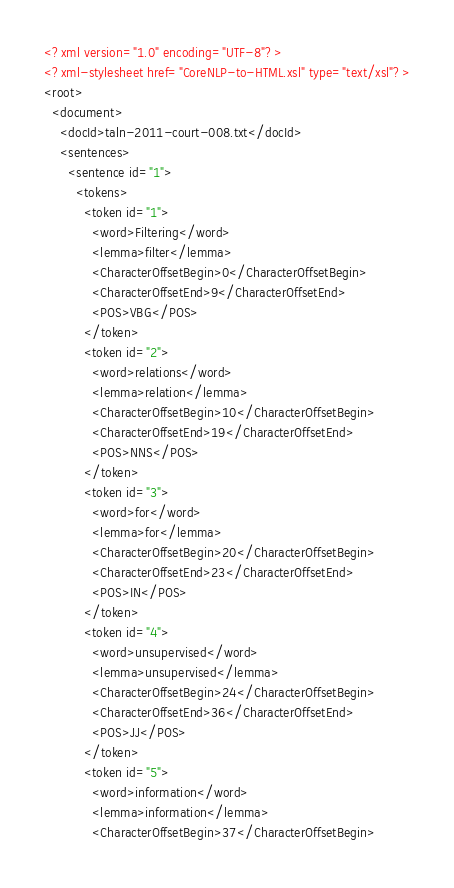Convert code to text. <code><loc_0><loc_0><loc_500><loc_500><_XML_><?xml version="1.0" encoding="UTF-8"?>
<?xml-stylesheet href="CoreNLP-to-HTML.xsl" type="text/xsl"?>
<root>
  <document>
    <docId>taln-2011-court-008.txt</docId>
    <sentences>
      <sentence id="1">
        <tokens>
          <token id="1">
            <word>Filtering</word>
            <lemma>filter</lemma>
            <CharacterOffsetBegin>0</CharacterOffsetBegin>
            <CharacterOffsetEnd>9</CharacterOffsetEnd>
            <POS>VBG</POS>
          </token>
          <token id="2">
            <word>relations</word>
            <lemma>relation</lemma>
            <CharacterOffsetBegin>10</CharacterOffsetBegin>
            <CharacterOffsetEnd>19</CharacterOffsetEnd>
            <POS>NNS</POS>
          </token>
          <token id="3">
            <word>for</word>
            <lemma>for</lemma>
            <CharacterOffsetBegin>20</CharacterOffsetBegin>
            <CharacterOffsetEnd>23</CharacterOffsetEnd>
            <POS>IN</POS>
          </token>
          <token id="4">
            <word>unsupervised</word>
            <lemma>unsupervised</lemma>
            <CharacterOffsetBegin>24</CharacterOffsetBegin>
            <CharacterOffsetEnd>36</CharacterOffsetEnd>
            <POS>JJ</POS>
          </token>
          <token id="5">
            <word>information</word>
            <lemma>information</lemma>
            <CharacterOffsetBegin>37</CharacterOffsetBegin></code> 